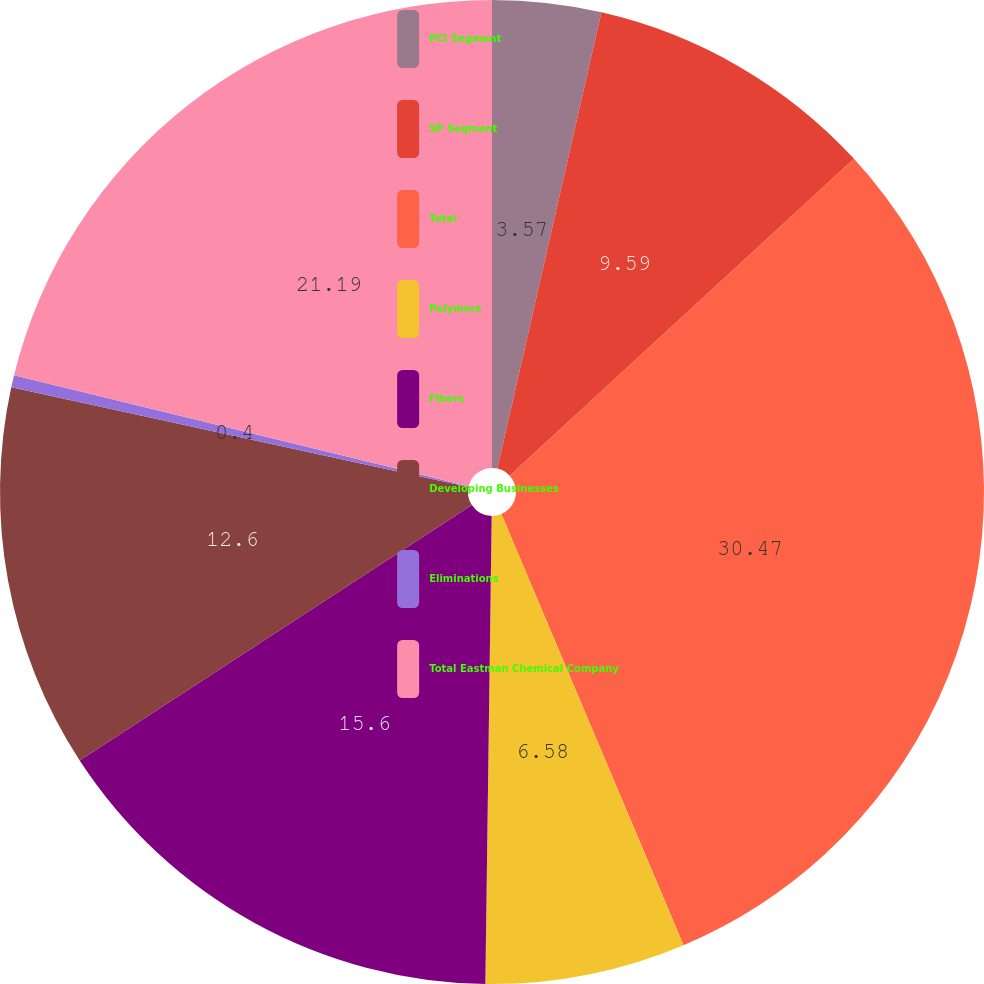<chart> <loc_0><loc_0><loc_500><loc_500><pie_chart><fcel>PCI Segment<fcel>SP Segment<fcel>Total<fcel>Polymers<fcel>Fibers<fcel>Developing Businesses<fcel>Eliminations<fcel>Total Eastman Chemical Company<nl><fcel>3.57%<fcel>9.59%<fcel>30.48%<fcel>6.58%<fcel>15.6%<fcel>12.6%<fcel>0.4%<fcel>21.19%<nl></chart> 